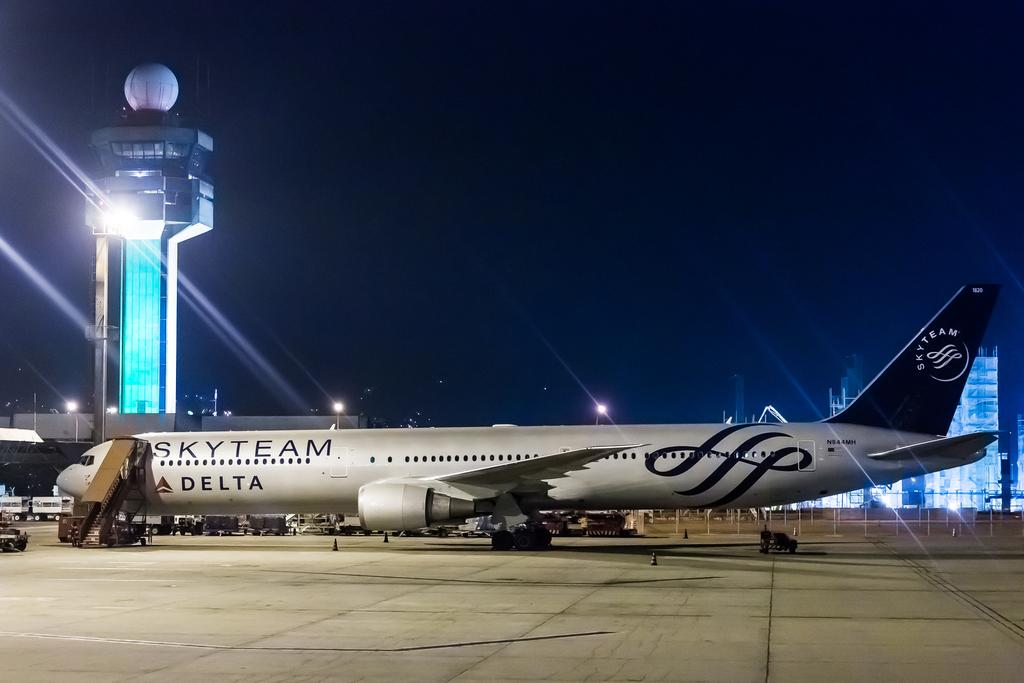<image>
Share a concise interpretation of the image provided. A delta airplane sicks on the runway at night time. 